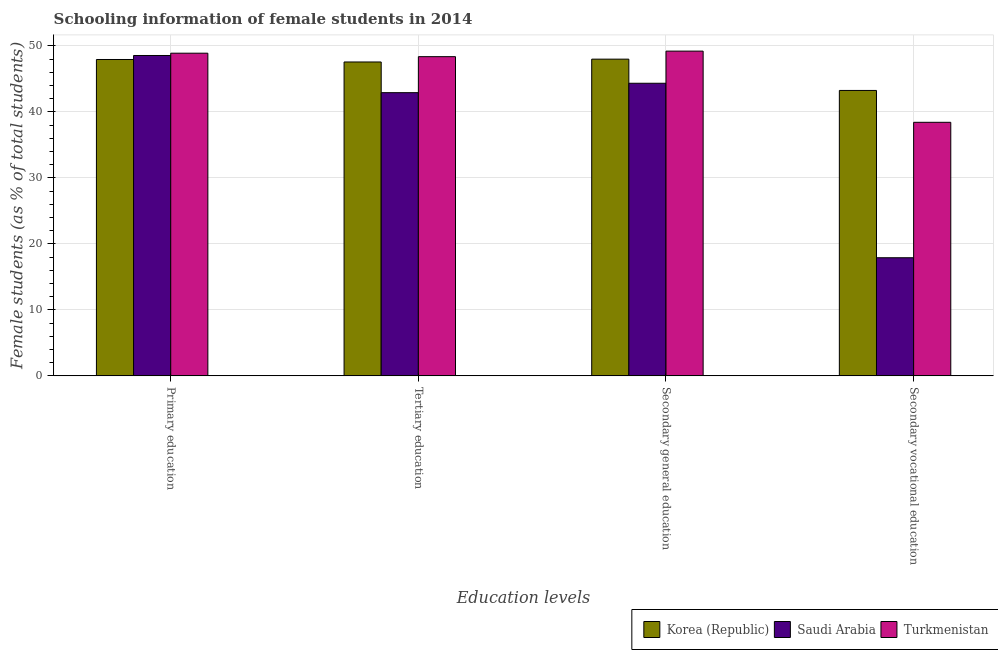How many different coloured bars are there?
Keep it short and to the point. 3. How many bars are there on the 1st tick from the left?
Your response must be concise. 3. How many bars are there on the 1st tick from the right?
Your response must be concise. 3. What is the percentage of female students in tertiary education in Turkmenistan?
Keep it short and to the point. 48.38. Across all countries, what is the maximum percentage of female students in secondary education?
Give a very brief answer. 49.22. Across all countries, what is the minimum percentage of female students in secondary vocational education?
Your answer should be very brief. 17.91. In which country was the percentage of female students in primary education maximum?
Provide a succinct answer. Turkmenistan. What is the total percentage of female students in secondary vocational education in the graph?
Provide a succinct answer. 99.6. What is the difference between the percentage of female students in primary education in Saudi Arabia and that in Turkmenistan?
Make the answer very short. -0.35. What is the difference between the percentage of female students in primary education in Korea (Republic) and the percentage of female students in secondary vocational education in Saudi Arabia?
Ensure brevity in your answer.  30.05. What is the average percentage of female students in secondary vocational education per country?
Offer a terse response. 33.2. What is the difference between the percentage of female students in tertiary education and percentage of female students in secondary education in Turkmenistan?
Ensure brevity in your answer.  -0.84. In how many countries, is the percentage of female students in primary education greater than 14 %?
Your response must be concise. 3. What is the ratio of the percentage of female students in secondary education in Turkmenistan to that in Saudi Arabia?
Offer a terse response. 1.11. Is the percentage of female students in secondary vocational education in Saudi Arabia less than that in Turkmenistan?
Make the answer very short. Yes. What is the difference between the highest and the second highest percentage of female students in secondary education?
Make the answer very short. 1.22. What is the difference between the highest and the lowest percentage of female students in primary education?
Your response must be concise. 0.95. In how many countries, is the percentage of female students in secondary vocational education greater than the average percentage of female students in secondary vocational education taken over all countries?
Make the answer very short. 2. What does the 2nd bar from the left in Secondary vocational education represents?
Provide a succinct answer. Saudi Arabia. What does the 1st bar from the right in Tertiary education represents?
Keep it short and to the point. Turkmenistan. What is the difference between two consecutive major ticks on the Y-axis?
Your response must be concise. 10. Are the values on the major ticks of Y-axis written in scientific E-notation?
Make the answer very short. No. Where does the legend appear in the graph?
Offer a very short reply. Bottom right. How are the legend labels stacked?
Make the answer very short. Horizontal. What is the title of the graph?
Provide a succinct answer. Schooling information of female students in 2014. What is the label or title of the X-axis?
Ensure brevity in your answer.  Education levels. What is the label or title of the Y-axis?
Your response must be concise. Female students (as % of total students). What is the Female students (as % of total students) in Korea (Republic) in Primary education?
Offer a very short reply. 47.95. What is the Female students (as % of total students) of Saudi Arabia in Primary education?
Provide a short and direct response. 48.56. What is the Female students (as % of total students) of Turkmenistan in Primary education?
Offer a terse response. 48.91. What is the Female students (as % of total students) of Korea (Republic) in Tertiary education?
Provide a short and direct response. 47.58. What is the Female students (as % of total students) of Saudi Arabia in Tertiary education?
Give a very brief answer. 42.92. What is the Female students (as % of total students) of Turkmenistan in Tertiary education?
Keep it short and to the point. 48.38. What is the Female students (as % of total students) of Korea (Republic) in Secondary general education?
Make the answer very short. 48.01. What is the Female students (as % of total students) in Saudi Arabia in Secondary general education?
Your answer should be compact. 44.35. What is the Female students (as % of total students) of Turkmenistan in Secondary general education?
Provide a succinct answer. 49.22. What is the Female students (as % of total students) of Korea (Republic) in Secondary vocational education?
Provide a succinct answer. 43.26. What is the Female students (as % of total students) in Saudi Arabia in Secondary vocational education?
Your answer should be compact. 17.91. What is the Female students (as % of total students) of Turkmenistan in Secondary vocational education?
Offer a terse response. 38.43. Across all Education levels, what is the maximum Female students (as % of total students) in Korea (Republic)?
Offer a very short reply. 48.01. Across all Education levels, what is the maximum Female students (as % of total students) in Saudi Arabia?
Your answer should be compact. 48.56. Across all Education levels, what is the maximum Female students (as % of total students) of Turkmenistan?
Ensure brevity in your answer.  49.22. Across all Education levels, what is the minimum Female students (as % of total students) of Korea (Republic)?
Offer a very short reply. 43.26. Across all Education levels, what is the minimum Female students (as % of total students) in Saudi Arabia?
Your answer should be compact. 17.91. Across all Education levels, what is the minimum Female students (as % of total students) in Turkmenistan?
Ensure brevity in your answer.  38.43. What is the total Female students (as % of total students) of Korea (Republic) in the graph?
Make the answer very short. 186.79. What is the total Female students (as % of total students) in Saudi Arabia in the graph?
Offer a terse response. 153.74. What is the total Female students (as % of total students) in Turkmenistan in the graph?
Your response must be concise. 184.94. What is the difference between the Female students (as % of total students) in Korea (Republic) in Primary education and that in Tertiary education?
Your answer should be compact. 0.38. What is the difference between the Female students (as % of total students) in Saudi Arabia in Primary education and that in Tertiary education?
Make the answer very short. 5.63. What is the difference between the Female students (as % of total students) in Turkmenistan in Primary education and that in Tertiary education?
Give a very brief answer. 0.53. What is the difference between the Female students (as % of total students) in Korea (Republic) in Primary education and that in Secondary general education?
Offer a terse response. -0.05. What is the difference between the Female students (as % of total students) of Saudi Arabia in Primary education and that in Secondary general education?
Provide a short and direct response. 4.21. What is the difference between the Female students (as % of total students) in Turkmenistan in Primary education and that in Secondary general education?
Your response must be concise. -0.32. What is the difference between the Female students (as % of total students) in Korea (Republic) in Primary education and that in Secondary vocational education?
Provide a succinct answer. 4.69. What is the difference between the Female students (as % of total students) in Saudi Arabia in Primary education and that in Secondary vocational education?
Offer a terse response. 30.65. What is the difference between the Female students (as % of total students) of Turkmenistan in Primary education and that in Secondary vocational education?
Provide a succinct answer. 10.47. What is the difference between the Female students (as % of total students) in Korea (Republic) in Tertiary education and that in Secondary general education?
Give a very brief answer. -0.43. What is the difference between the Female students (as % of total students) in Saudi Arabia in Tertiary education and that in Secondary general education?
Your response must be concise. -1.43. What is the difference between the Female students (as % of total students) of Turkmenistan in Tertiary education and that in Secondary general education?
Offer a terse response. -0.84. What is the difference between the Female students (as % of total students) of Korea (Republic) in Tertiary education and that in Secondary vocational education?
Your answer should be very brief. 4.31. What is the difference between the Female students (as % of total students) in Saudi Arabia in Tertiary education and that in Secondary vocational education?
Your answer should be compact. 25.02. What is the difference between the Female students (as % of total students) in Turkmenistan in Tertiary education and that in Secondary vocational education?
Ensure brevity in your answer.  9.95. What is the difference between the Female students (as % of total students) in Korea (Republic) in Secondary general education and that in Secondary vocational education?
Make the answer very short. 4.74. What is the difference between the Female students (as % of total students) of Saudi Arabia in Secondary general education and that in Secondary vocational education?
Your response must be concise. 26.45. What is the difference between the Female students (as % of total students) of Turkmenistan in Secondary general education and that in Secondary vocational education?
Ensure brevity in your answer.  10.79. What is the difference between the Female students (as % of total students) of Korea (Republic) in Primary education and the Female students (as % of total students) of Saudi Arabia in Tertiary education?
Ensure brevity in your answer.  5.03. What is the difference between the Female students (as % of total students) of Korea (Republic) in Primary education and the Female students (as % of total students) of Turkmenistan in Tertiary education?
Give a very brief answer. -0.43. What is the difference between the Female students (as % of total students) in Saudi Arabia in Primary education and the Female students (as % of total students) in Turkmenistan in Tertiary education?
Keep it short and to the point. 0.18. What is the difference between the Female students (as % of total students) in Korea (Republic) in Primary education and the Female students (as % of total students) in Saudi Arabia in Secondary general education?
Provide a short and direct response. 3.6. What is the difference between the Female students (as % of total students) of Korea (Republic) in Primary education and the Female students (as % of total students) of Turkmenistan in Secondary general education?
Make the answer very short. -1.27. What is the difference between the Female students (as % of total students) in Saudi Arabia in Primary education and the Female students (as % of total students) in Turkmenistan in Secondary general education?
Give a very brief answer. -0.66. What is the difference between the Female students (as % of total students) in Korea (Republic) in Primary education and the Female students (as % of total students) in Saudi Arabia in Secondary vocational education?
Offer a very short reply. 30.05. What is the difference between the Female students (as % of total students) in Korea (Republic) in Primary education and the Female students (as % of total students) in Turkmenistan in Secondary vocational education?
Keep it short and to the point. 9.52. What is the difference between the Female students (as % of total students) of Saudi Arabia in Primary education and the Female students (as % of total students) of Turkmenistan in Secondary vocational education?
Your answer should be very brief. 10.13. What is the difference between the Female students (as % of total students) in Korea (Republic) in Tertiary education and the Female students (as % of total students) in Saudi Arabia in Secondary general education?
Give a very brief answer. 3.22. What is the difference between the Female students (as % of total students) in Korea (Republic) in Tertiary education and the Female students (as % of total students) in Turkmenistan in Secondary general education?
Make the answer very short. -1.65. What is the difference between the Female students (as % of total students) in Saudi Arabia in Tertiary education and the Female students (as % of total students) in Turkmenistan in Secondary general education?
Provide a short and direct response. -6.3. What is the difference between the Female students (as % of total students) in Korea (Republic) in Tertiary education and the Female students (as % of total students) in Saudi Arabia in Secondary vocational education?
Provide a succinct answer. 29.67. What is the difference between the Female students (as % of total students) of Korea (Republic) in Tertiary education and the Female students (as % of total students) of Turkmenistan in Secondary vocational education?
Provide a succinct answer. 9.14. What is the difference between the Female students (as % of total students) in Saudi Arabia in Tertiary education and the Female students (as % of total students) in Turkmenistan in Secondary vocational education?
Your answer should be very brief. 4.49. What is the difference between the Female students (as % of total students) in Korea (Republic) in Secondary general education and the Female students (as % of total students) in Saudi Arabia in Secondary vocational education?
Provide a succinct answer. 30.1. What is the difference between the Female students (as % of total students) of Korea (Republic) in Secondary general education and the Female students (as % of total students) of Turkmenistan in Secondary vocational education?
Make the answer very short. 9.57. What is the difference between the Female students (as % of total students) of Saudi Arabia in Secondary general education and the Female students (as % of total students) of Turkmenistan in Secondary vocational education?
Keep it short and to the point. 5.92. What is the average Female students (as % of total students) of Korea (Republic) per Education levels?
Offer a very short reply. 46.7. What is the average Female students (as % of total students) in Saudi Arabia per Education levels?
Offer a terse response. 38.44. What is the average Female students (as % of total students) of Turkmenistan per Education levels?
Keep it short and to the point. 46.24. What is the difference between the Female students (as % of total students) in Korea (Republic) and Female students (as % of total students) in Saudi Arabia in Primary education?
Keep it short and to the point. -0.61. What is the difference between the Female students (as % of total students) of Korea (Republic) and Female students (as % of total students) of Turkmenistan in Primary education?
Provide a succinct answer. -0.95. What is the difference between the Female students (as % of total students) in Saudi Arabia and Female students (as % of total students) in Turkmenistan in Primary education?
Provide a short and direct response. -0.35. What is the difference between the Female students (as % of total students) in Korea (Republic) and Female students (as % of total students) in Saudi Arabia in Tertiary education?
Offer a terse response. 4.65. What is the difference between the Female students (as % of total students) in Korea (Republic) and Female students (as % of total students) in Turkmenistan in Tertiary education?
Keep it short and to the point. -0.81. What is the difference between the Female students (as % of total students) in Saudi Arabia and Female students (as % of total students) in Turkmenistan in Tertiary education?
Keep it short and to the point. -5.46. What is the difference between the Female students (as % of total students) in Korea (Republic) and Female students (as % of total students) in Saudi Arabia in Secondary general education?
Provide a short and direct response. 3.65. What is the difference between the Female students (as % of total students) in Korea (Republic) and Female students (as % of total students) in Turkmenistan in Secondary general education?
Offer a terse response. -1.22. What is the difference between the Female students (as % of total students) of Saudi Arabia and Female students (as % of total students) of Turkmenistan in Secondary general education?
Give a very brief answer. -4.87. What is the difference between the Female students (as % of total students) in Korea (Republic) and Female students (as % of total students) in Saudi Arabia in Secondary vocational education?
Ensure brevity in your answer.  25.36. What is the difference between the Female students (as % of total students) in Korea (Republic) and Female students (as % of total students) in Turkmenistan in Secondary vocational education?
Give a very brief answer. 4.83. What is the difference between the Female students (as % of total students) of Saudi Arabia and Female students (as % of total students) of Turkmenistan in Secondary vocational education?
Give a very brief answer. -20.53. What is the ratio of the Female students (as % of total students) in Korea (Republic) in Primary education to that in Tertiary education?
Ensure brevity in your answer.  1.01. What is the ratio of the Female students (as % of total students) in Saudi Arabia in Primary education to that in Tertiary education?
Keep it short and to the point. 1.13. What is the ratio of the Female students (as % of total students) in Turkmenistan in Primary education to that in Tertiary education?
Your response must be concise. 1.01. What is the ratio of the Female students (as % of total students) of Korea (Republic) in Primary education to that in Secondary general education?
Ensure brevity in your answer.  1. What is the ratio of the Female students (as % of total students) of Saudi Arabia in Primary education to that in Secondary general education?
Your response must be concise. 1.09. What is the ratio of the Female students (as % of total students) in Korea (Republic) in Primary education to that in Secondary vocational education?
Provide a succinct answer. 1.11. What is the ratio of the Female students (as % of total students) of Saudi Arabia in Primary education to that in Secondary vocational education?
Your answer should be compact. 2.71. What is the ratio of the Female students (as % of total students) of Turkmenistan in Primary education to that in Secondary vocational education?
Offer a terse response. 1.27. What is the ratio of the Female students (as % of total students) in Saudi Arabia in Tertiary education to that in Secondary general education?
Give a very brief answer. 0.97. What is the ratio of the Female students (as % of total students) in Turkmenistan in Tertiary education to that in Secondary general education?
Offer a very short reply. 0.98. What is the ratio of the Female students (as % of total students) in Korea (Republic) in Tertiary education to that in Secondary vocational education?
Your response must be concise. 1.1. What is the ratio of the Female students (as % of total students) in Saudi Arabia in Tertiary education to that in Secondary vocational education?
Offer a terse response. 2.4. What is the ratio of the Female students (as % of total students) of Turkmenistan in Tertiary education to that in Secondary vocational education?
Your response must be concise. 1.26. What is the ratio of the Female students (as % of total students) in Korea (Republic) in Secondary general education to that in Secondary vocational education?
Offer a terse response. 1.11. What is the ratio of the Female students (as % of total students) in Saudi Arabia in Secondary general education to that in Secondary vocational education?
Your response must be concise. 2.48. What is the ratio of the Female students (as % of total students) in Turkmenistan in Secondary general education to that in Secondary vocational education?
Your response must be concise. 1.28. What is the difference between the highest and the second highest Female students (as % of total students) of Korea (Republic)?
Provide a succinct answer. 0.05. What is the difference between the highest and the second highest Female students (as % of total students) of Saudi Arabia?
Offer a terse response. 4.21. What is the difference between the highest and the second highest Female students (as % of total students) in Turkmenistan?
Make the answer very short. 0.32. What is the difference between the highest and the lowest Female students (as % of total students) of Korea (Republic)?
Offer a very short reply. 4.74. What is the difference between the highest and the lowest Female students (as % of total students) of Saudi Arabia?
Provide a succinct answer. 30.65. What is the difference between the highest and the lowest Female students (as % of total students) of Turkmenistan?
Provide a short and direct response. 10.79. 